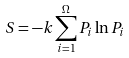<formula> <loc_0><loc_0><loc_500><loc_500>S = - k \sum _ { i = 1 } ^ { \Omega } P _ { i } \ln P _ { i }</formula> 